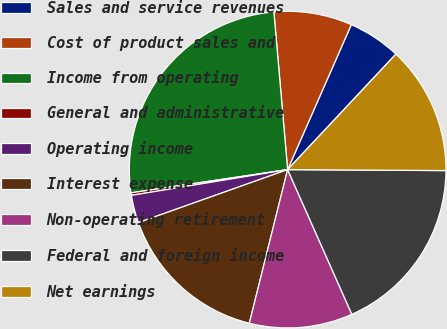Convert chart to OTSL. <chart><loc_0><loc_0><loc_500><loc_500><pie_chart><fcel>Sales and service revenues<fcel>Cost of product sales and<fcel>Income from operating<fcel>General and administrative<fcel>Operating income<fcel>Interest expense<fcel>Non-operating retirement<fcel>Federal and foreign income<fcel>Net earnings<nl><fcel>5.4%<fcel>7.97%<fcel>25.96%<fcel>0.26%<fcel>2.83%<fcel>15.68%<fcel>10.54%<fcel>18.25%<fcel>13.11%<nl></chart> 